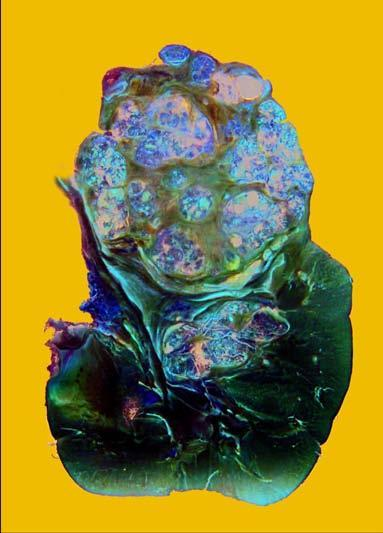what does rest of the kidney have?
Answer the question using a single word or phrase. Reniform contour 